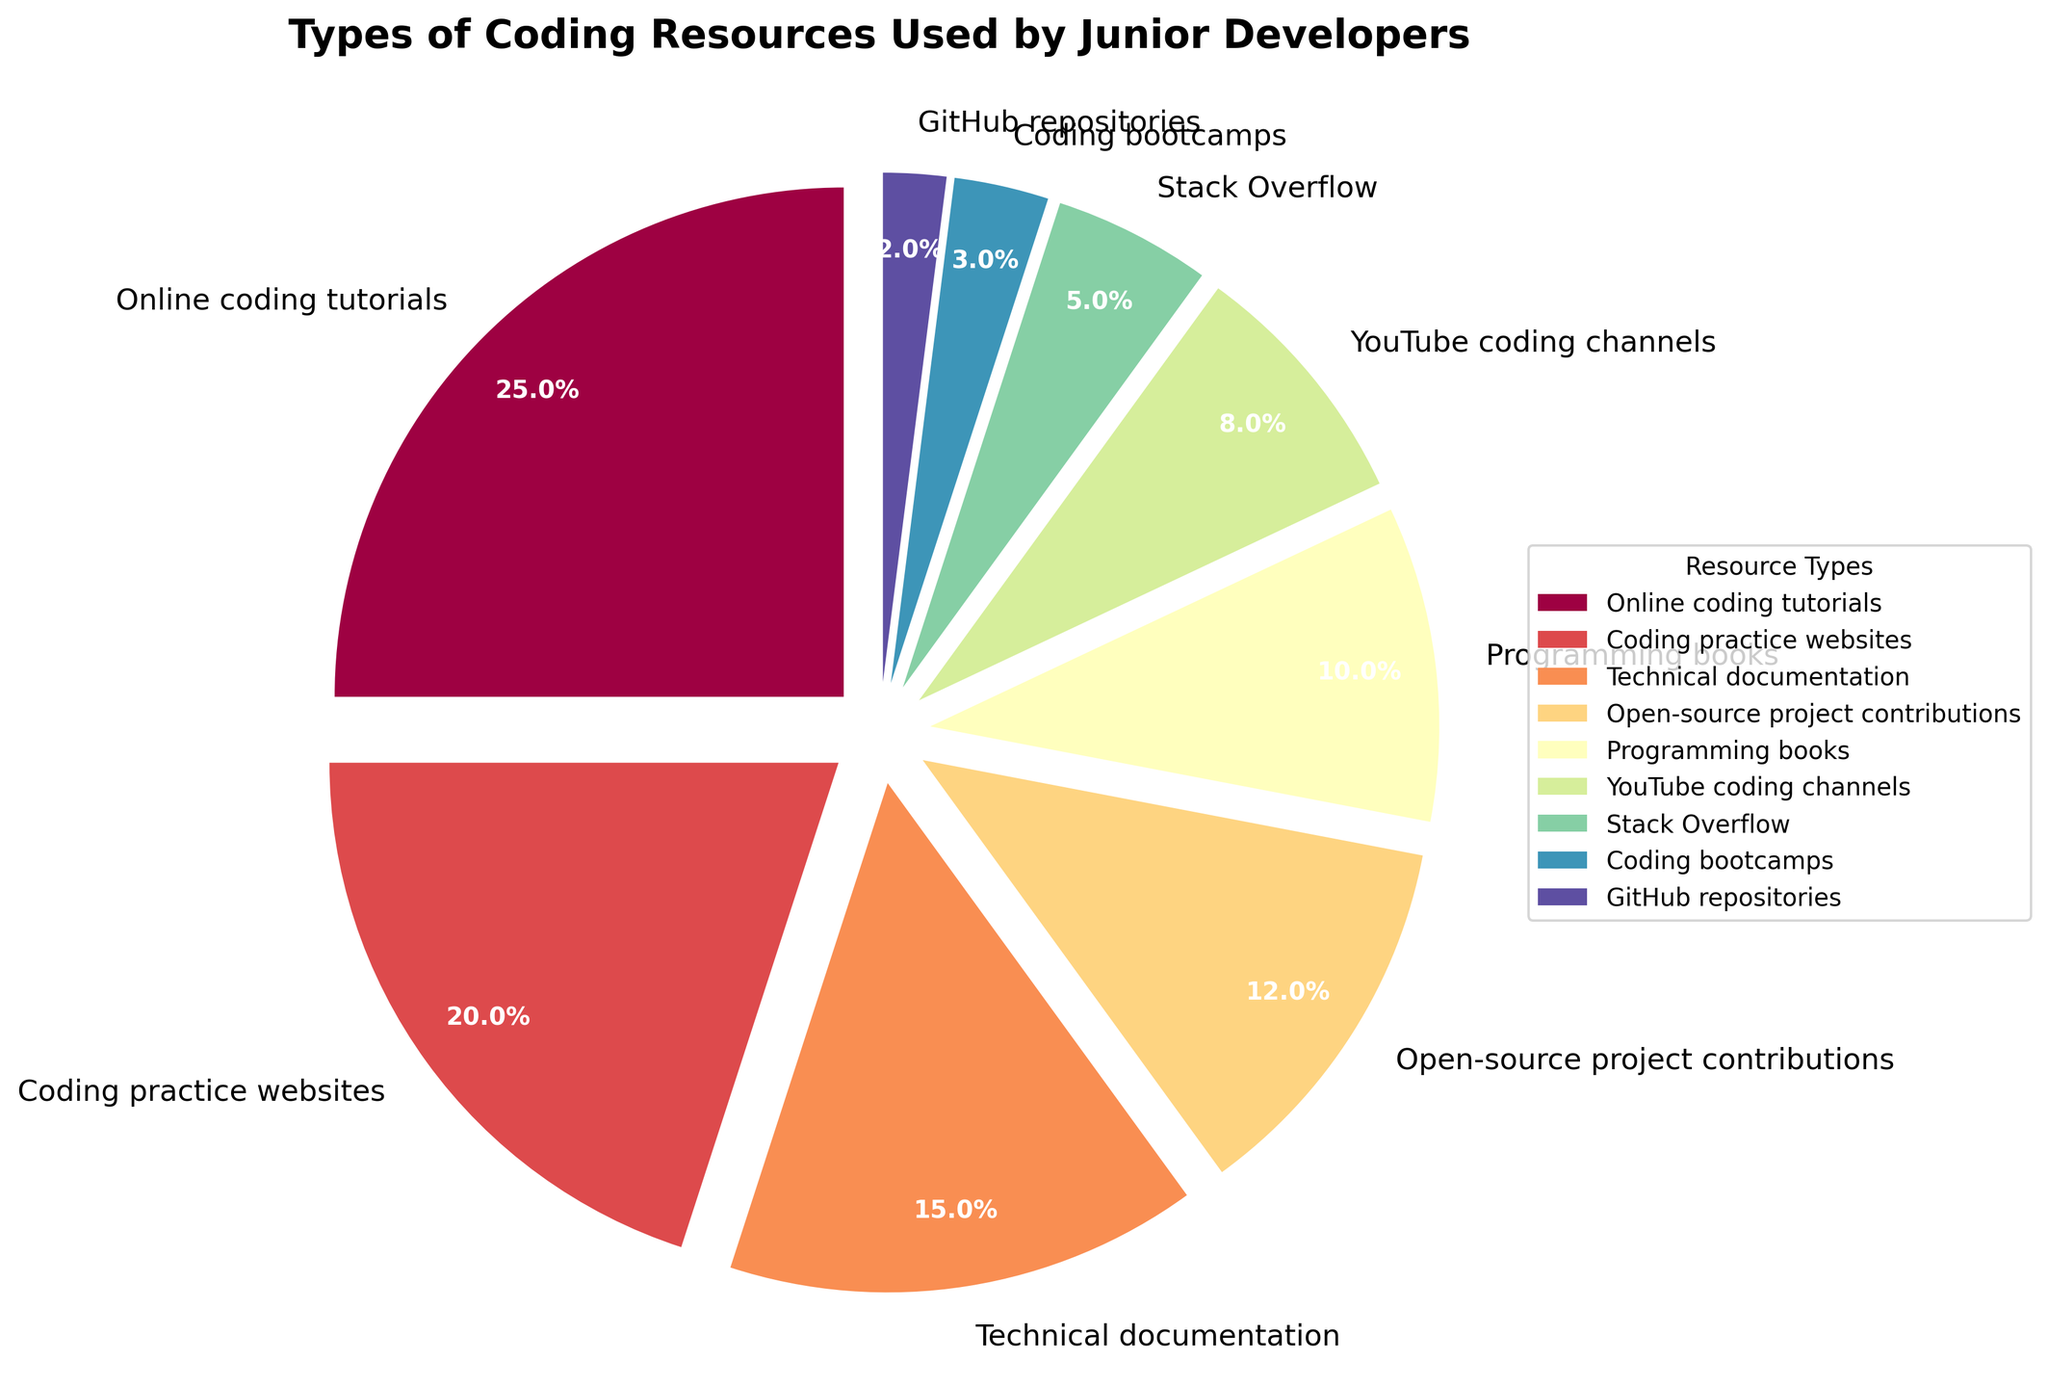What percentage of junior developers use online coding tutorials? Online coding tutorials represent one slice of the pie chart with the label 'Online coding tutorials' and the percentage on it is 25%.
Answer: 25% Which resource type is used more frequently: YouTube coding channels or GitHub repositories? By looking at the chart, the slice labeled 'YouTube coding channels' is 8%, and the slice labeled 'GitHub repositories' is 2%. 8% is greater than 2%, indicating that YouTube coding channels are used more frequently.
Answer: YouTube coding channels What is the total percentage of junior developers using technical documentation and programming books? From the pie chart, the percentage for 'Technical documentation' is 15% and for 'Programming books' is 10%. Add these two percentages: 15% + 10% = 25%.
Answer: 25% Which resource is the least used by junior developers for self-learning? The smallest slice in the pie chart represents 'GitHub repositories' with 2%.
Answer: GitHub repositories Are more developers using coding practice websites than programming books? The pie chart shows 'Coding practice websites' at 20% and 'Programming books' at 10%. Since 20% is greater than 10%, more developers use coding practice websites.
Answer: Yes Which coding resource has the second highest usage among junior developers? The pie chart shows the largest slice is 'Online coding tutorials' at 25%. The next largest slice is 'Coding practice websites' at 20%. Therefore, 'Coding practice websites' has the second highest usage.
Answer: Coding practice websites Combine the percentages for open-source project contributions, Stack Overflow, and coding bootcamps. What is the total? The pie chart shows 'Open-source project contributions' at 12%, 'Stack Overflow' at 5%, and 'Coding bootcamps' at 3%. Add these percentages together: 12% + 5% + 3% = 20%.
Answer: 20% Is the usage of online coding tutorials and coding practice websites together higher than the combined usage of technical documentation, YouTube coding channels, and Stack Overflow? Adding the percentages for 'Online coding tutorials' (25%) and 'Coding practice websites' (20%) results in 45%. Adding the percentages for 'Technical documentation' (15%), 'YouTube coding channels' (8%), and 'Stack Overflow' (5%) results in 28%. Since 45% is greater than 28%, the combined usage of online coding tutorials and coding practice websites is higher.
Answer: Yes What is the color of the slice representing the second least used resource? The resource labeled 'GitHub repositories' at 2% is the least used, and 'Coding bootcamps' at 3% is the second least used. The slice representing 'Coding bootcamps' is shaded in a specific color identifiable from the pie chart.
Answer: [Color corresponding to 'Coding bootcamps'] 